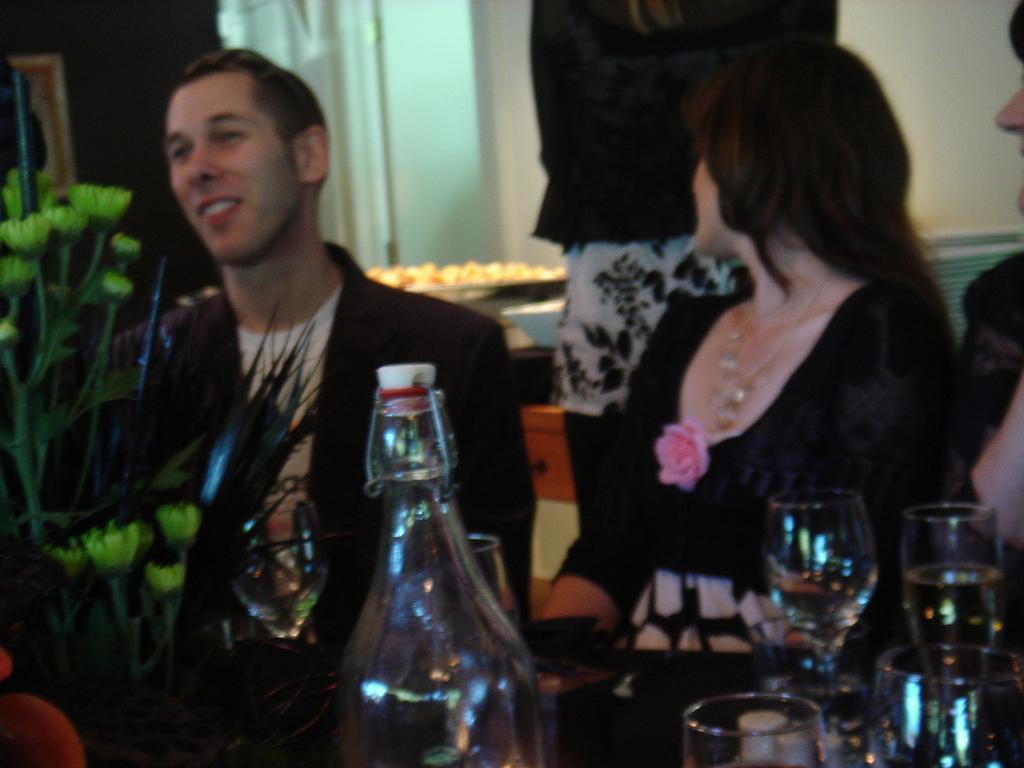In one or two sentences, can you explain what this image depicts? In this picture there are three people sitting on the chair and a person is standing at the back. There is a bottle, few glasses, plant on the table. A bowl, plate and some food is seen on the desk in the background. 